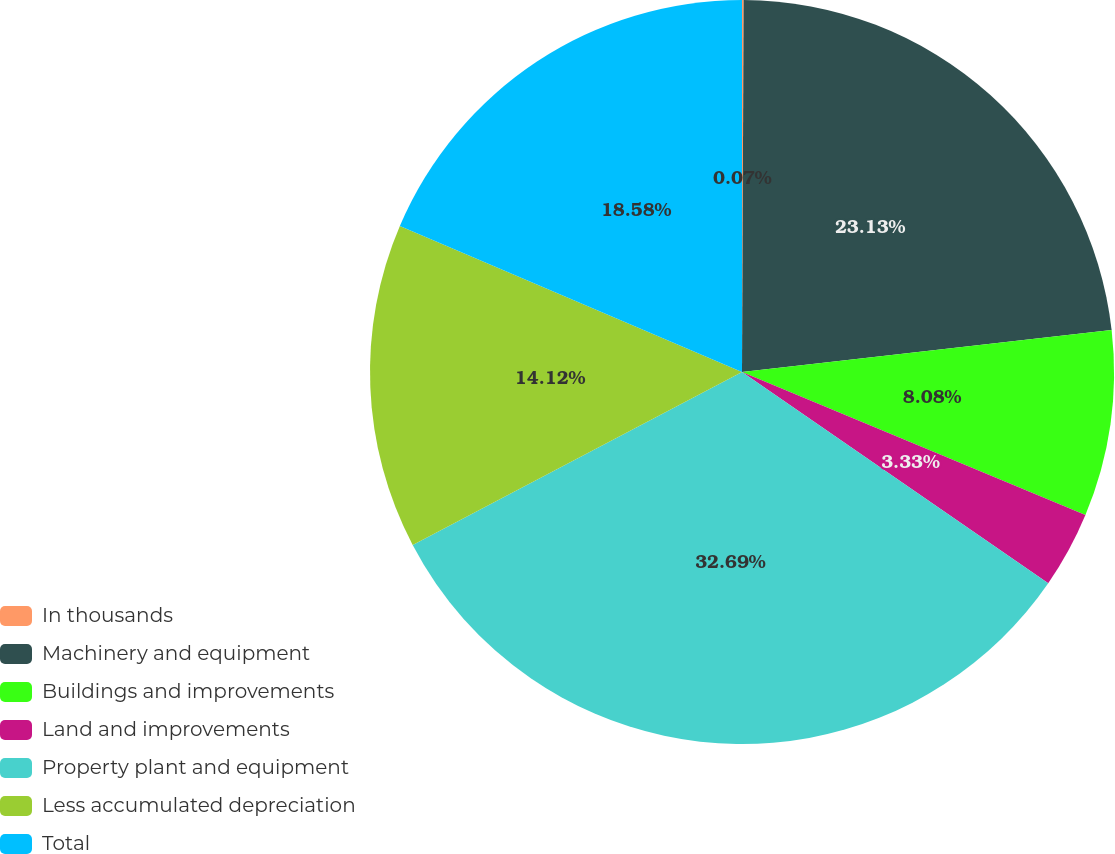Convert chart. <chart><loc_0><loc_0><loc_500><loc_500><pie_chart><fcel>In thousands<fcel>Machinery and equipment<fcel>Buildings and improvements<fcel>Land and improvements<fcel>Property plant and equipment<fcel>Less accumulated depreciation<fcel>Total<nl><fcel>0.07%<fcel>23.13%<fcel>8.08%<fcel>3.33%<fcel>32.69%<fcel>14.12%<fcel>18.58%<nl></chart> 